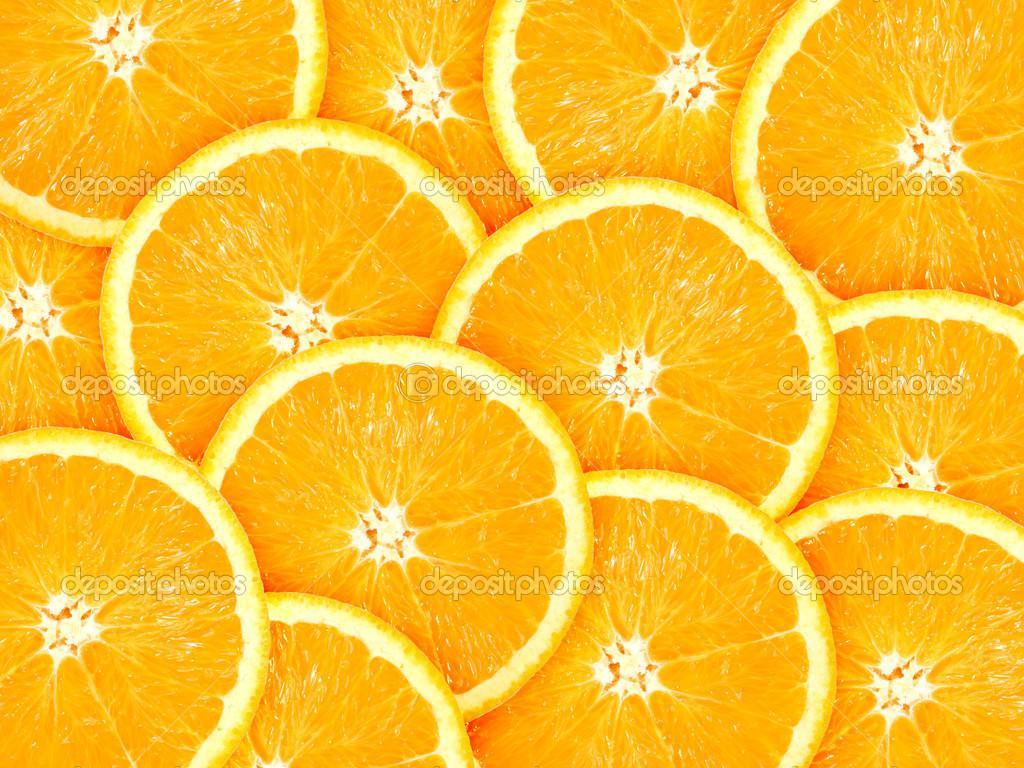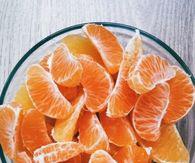The first image is the image on the left, the second image is the image on the right. Analyze the images presented: Is the assertion "In one image, the oranges are quartered and in the other they are sliced circles." valid? Answer yes or no. No. The first image is the image on the left, the second image is the image on the right. For the images displayed, is the sentence "There is fruit on a white surface." factually correct? Answer yes or no. No. 